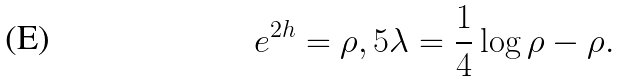<formula> <loc_0><loc_0><loc_500><loc_500>e ^ { 2 h } = \rho , 5 \lambda = \frac { 1 } { 4 } \log \rho - \rho .</formula> 